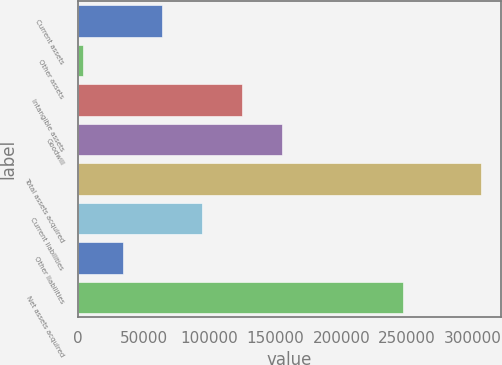Convert chart. <chart><loc_0><loc_0><loc_500><loc_500><bar_chart><fcel>Current assets<fcel>Other assets<fcel>Intangible assets<fcel>Goodwill<fcel>Total assets acquired<fcel>Current liabilities<fcel>Other liabilities<fcel>Net assets acquired<nl><fcel>64112.2<fcel>3730<fcel>124494<fcel>154686<fcel>305641<fcel>94303.3<fcel>33921.1<fcel>246861<nl></chart> 